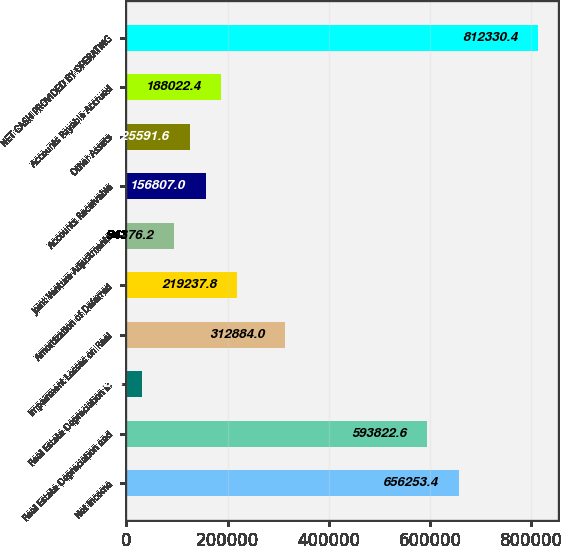Convert chart to OTSL. <chart><loc_0><loc_0><loc_500><loc_500><bar_chart><fcel>Net Income<fcel>Real Estate Depreciation and<fcel>Real Estate Depreciation in<fcel>Impairment Losses on Real<fcel>Amortization of Deferred<fcel>Joint Venture Adjustments<fcel>Accounts Receivable<fcel>Other Assets<fcel>Accounts Payable Accrued<fcel>NET CASH PROVIDED BY OPERATING<nl><fcel>656253<fcel>593823<fcel>31945.4<fcel>312884<fcel>219238<fcel>94376.2<fcel>156807<fcel>125592<fcel>188022<fcel>812330<nl></chart> 